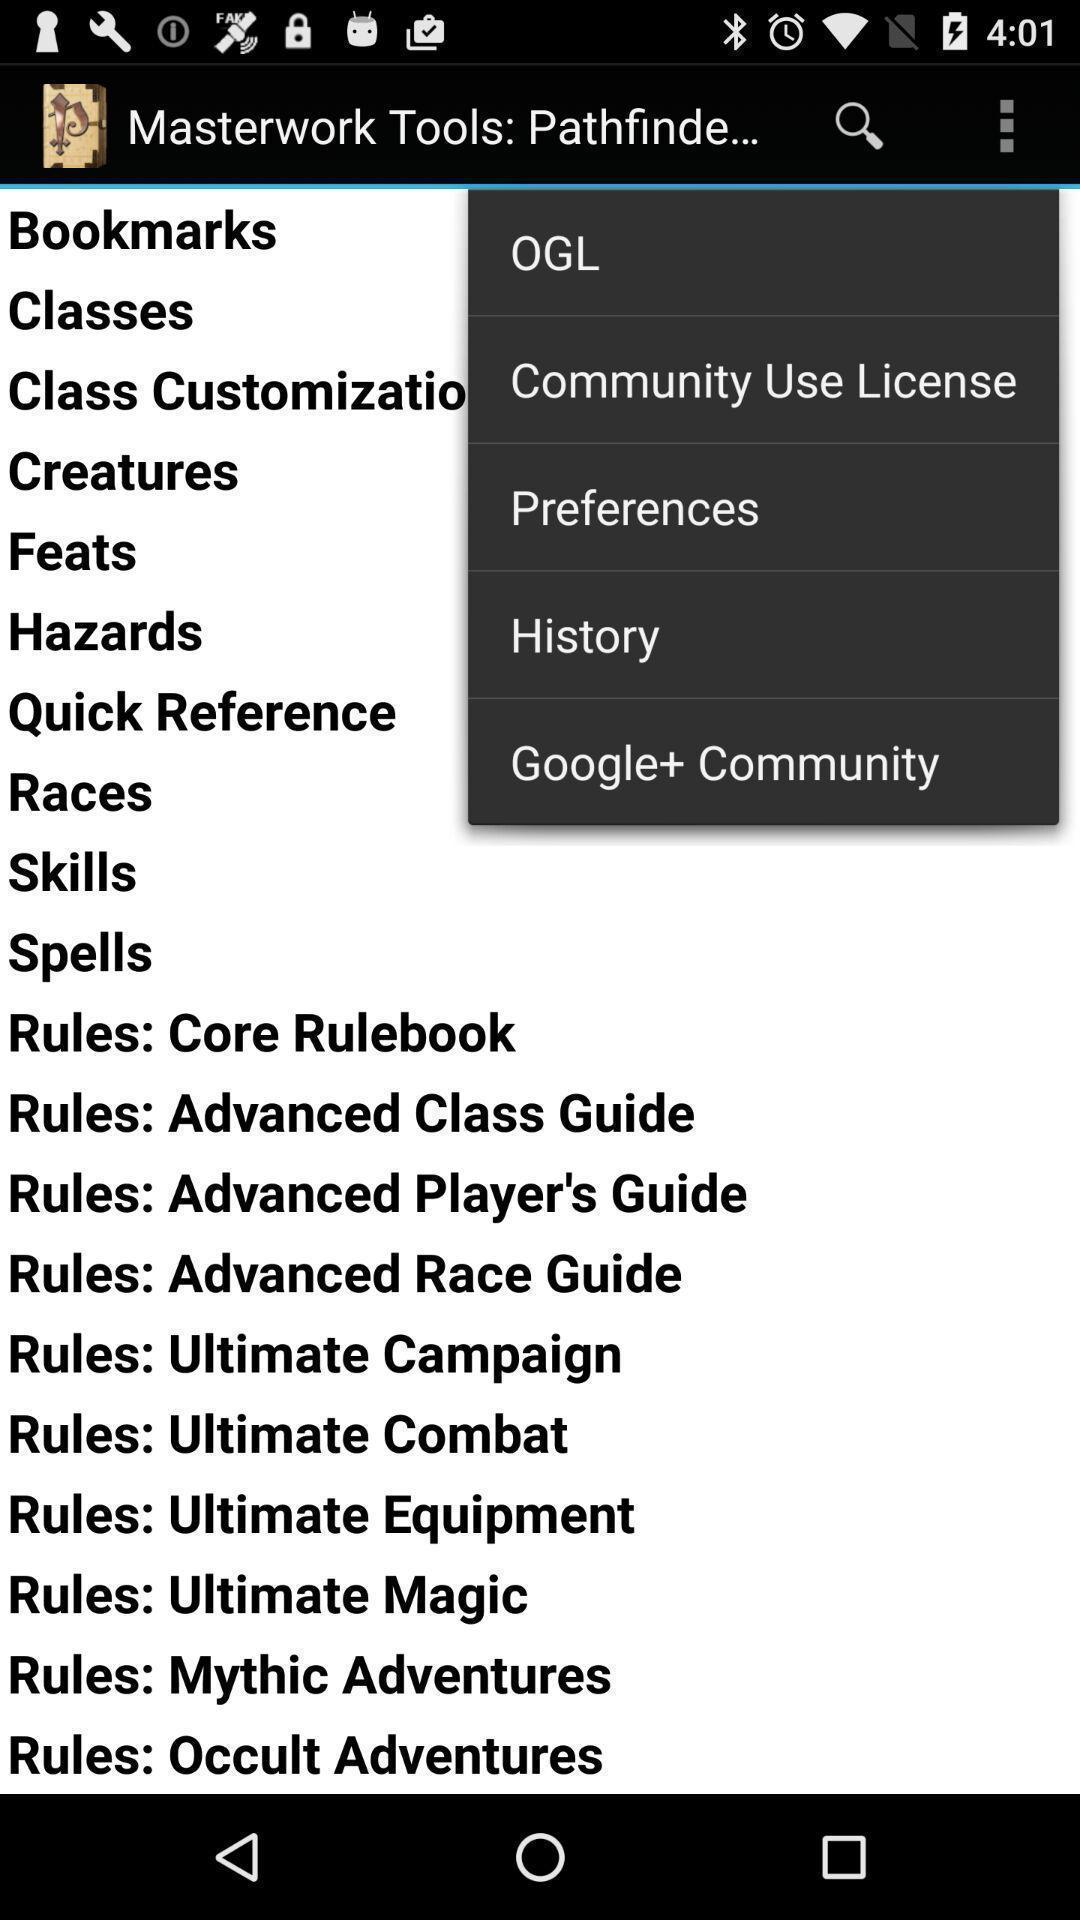Provide a detailed account of this screenshot. Screen displaying multiple options in a gaming application. 